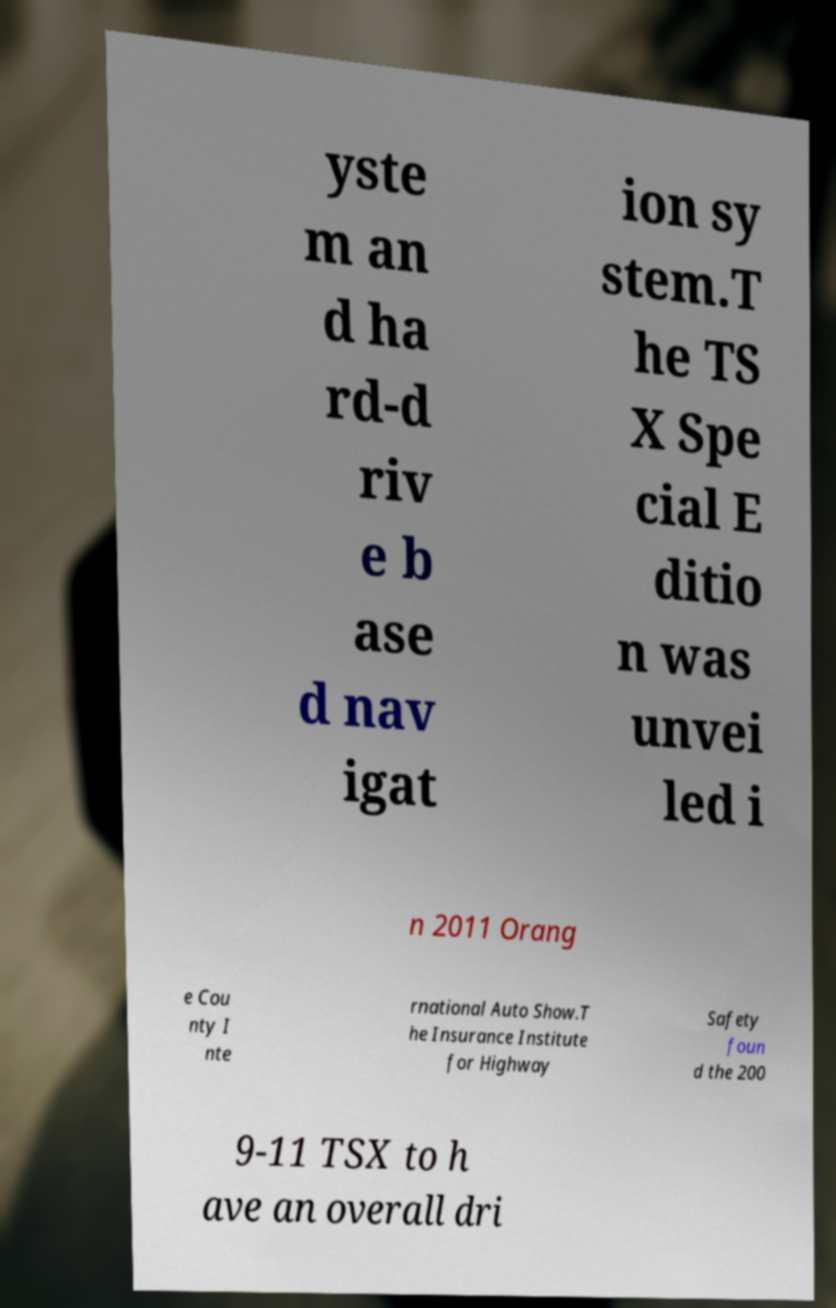For documentation purposes, I need the text within this image transcribed. Could you provide that? yste m an d ha rd-d riv e b ase d nav igat ion sy stem.T he TS X Spe cial E ditio n was unvei led i n 2011 Orang e Cou nty I nte rnational Auto Show.T he Insurance Institute for Highway Safety foun d the 200 9-11 TSX to h ave an overall dri 